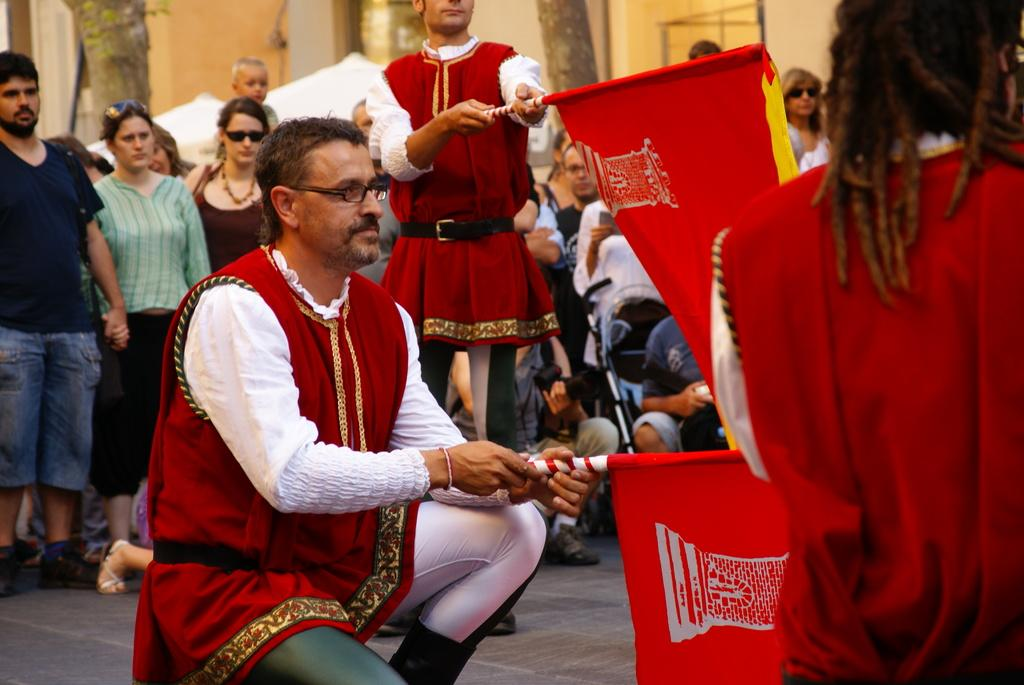What is the man in the image doing? The man is sitting in a squat position in the image. What is the man holding in the image? The man is holding a flag in the image. What can be seen in the background of the image? There is a building in the background of the image. What type of natural feature is visible in the image? There are tree trunks visible in the image. What is the position of the group of people in the image? The group of people is standing in the image. What time does the clock in the image show? There is no clock present in the image. What type of sand can be seen in the image? There is no sand present in the image. 